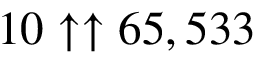<formula> <loc_0><loc_0><loc_500><loc_500>1 0 \uparrow \uparrow 6 5 , 5 3 3</formula> 